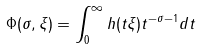Convert formula to latex. <formula><loc_0><loc_0><loc_500><loc_500>\Phi ( \sigma , \xi ) = \int _ { 0 } ^ { \infty } h ( t \xi ) t ^ { - \sigma - 1 } d t</formula> 